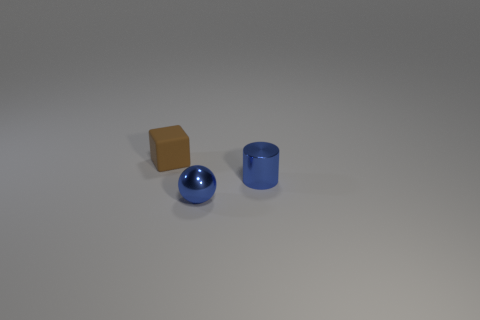Add 3 red balls. How many objects exist? 6 Subtract all balls. How many objects are left? 2 Add 1 blue cylinders. How many blue cylinders are left? 2 Add 1 tiny metallic cylinders. How many tiny metallic cylinders exist? 2 Subtract 0 brown spheres. How many objects are left? 3 Subtract all small brown metal objects. Subtract all tiny matte things. How many objects are left? 2 